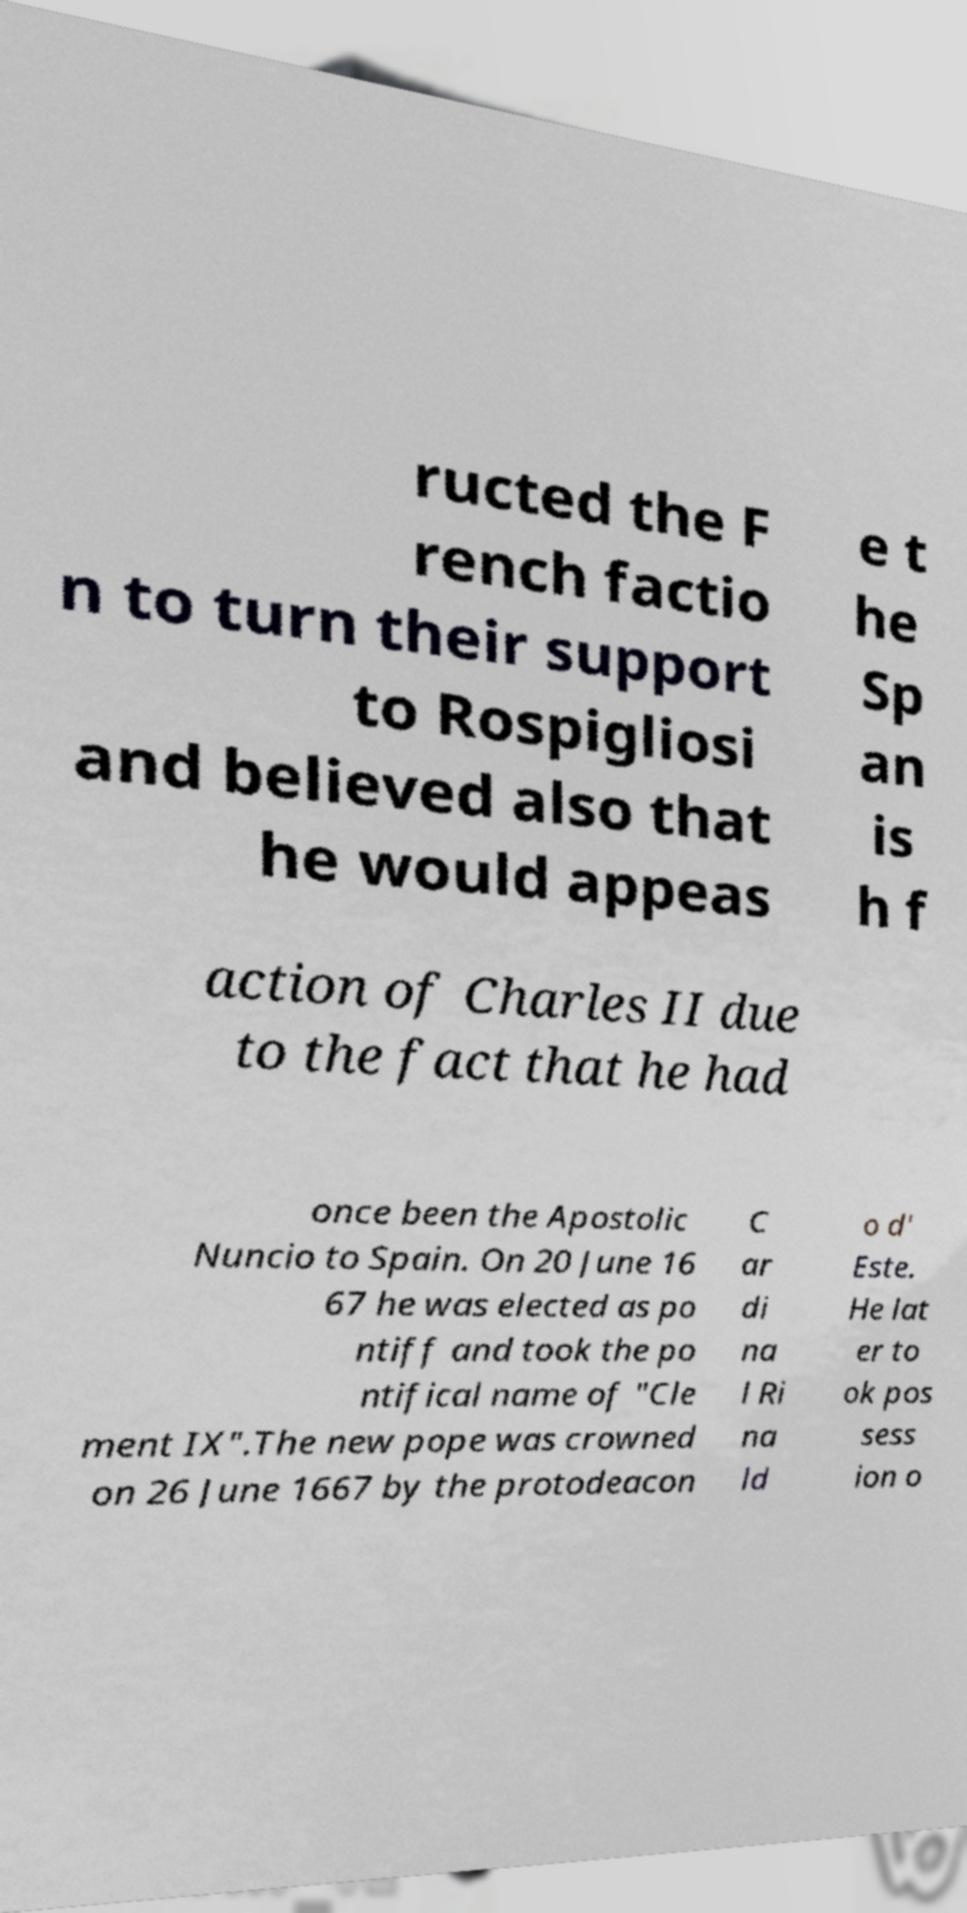Can you read and provide the text displayed in the image?This photo seems to have some interesting text. Can you extract and type it out for me? ructed the F rench factio n to turn their support to Rospigliosi and believed also that he would appeas e t he Sp an is h f action of Charles II due to the fact that he had once been the Apostolic Nuncio to Spain. On 20 June 16 67 he was elected as po ntiff and took the po ntifical name of "Cle ment IX".The new pope was crowned on 26 June 1667 by the protodeacon C ar di na l Ri na ld o d' Este. He lat er to ok pos sess ion o 